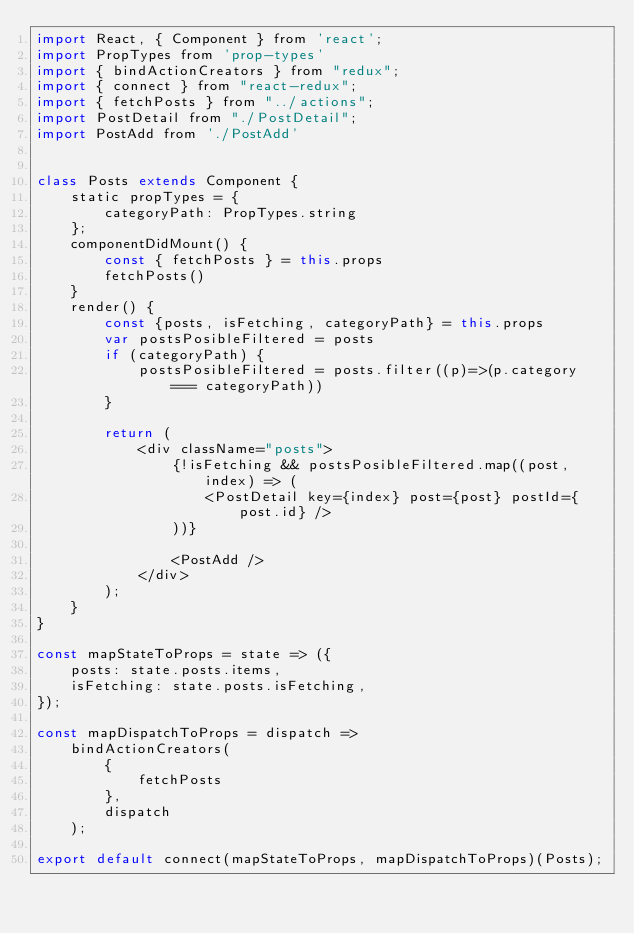<code> <loc_0><loc_0><loc_500><loc_500><_JavaScript_>import React, { Component } from 'react';
import PropTypes from 'prop-types'
import { bindActionCreators } from "redux";
import { connect } from "react-redux";
import { fetchPosts } from "../actions";
import PostDetail from "./PostDetail";
import PostAdd from './PostAdd'


class Posts extends Component {
	static propTypes = {
		categoryPath: PropTypes.string
	};
	componentDidMount() {
		const { fetchPosts } = this.props
		fetchPosts()
	}
	render() {
		const {posts, isFetching, categoryPath} = this.props
		var postsPosibleFiltered = posts
		if (categoryPath) {
			postsPosibleFiltered = posts.filter((p)=>(p.category === categoryPath))
		}

		return (
			<div className="posts">
				{!isFetching && postsPosibleFiltered.map((post, index) => (
					<PostDetail key={index} post={post} postId={post.id} />
				))}

				<PostAdd />
			</div>
		);
	}
}

const mapStateToProps = state => ({
	posts: state.posts.items,
	isFetching: state.posts.isFetching,
});

const mapDispatchToProps = dispatch =>
	bindActionCreators(
		{
			fetchPosts
		},
		dispatch
	);

export default connect(mapStateToProps, mapDispatchToProps)(Posts);</code> 